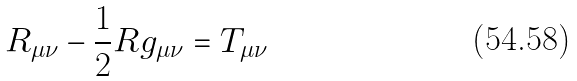<formula> <loc_0><loc_0><loc_500><loc_500>R _ { \mu \nu } - { \frac { 1 } { 2 } } R g _ { \mu \nu } = T _ { \mu \nu }</formula> 